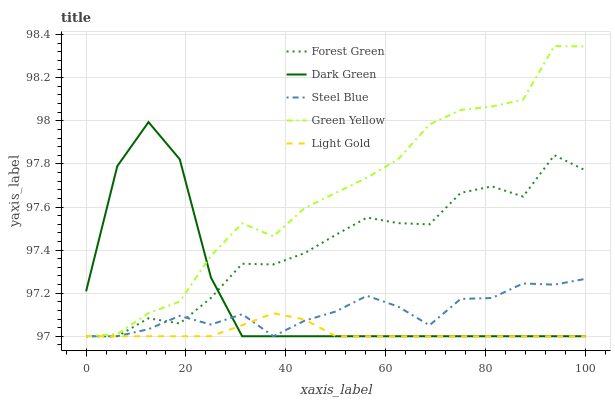Does Light Gold have the minimum area under the curve?
Answer yes or no. Yes. Does Green Yellow have the maximum area under the curve?
Answer yes or no. Yes. Does Green Yellow have the minimum area under the curve?
Answer yes or no. No. Does Light Gold have the maximum area under the curve?
Answer yes or no. No. Is Light Gold the smoothest?
Answer yes or no. Yes. Is Dark Green the roughest?
Answer yes or no. Yes. Is Green Yellow the smoothest?
Answer yes or no. No. Is Green Yellow the roughest?
Answer yes or no. No. Does Forest Green have the lowest value?
Answer yes or no. Yes. Does Green Yellow have the highest value?
Answer yes or no. Yes. Does Light Gold have the highest value?
Answer yes or no. No. Does Green Yellow intersect Dark Green?
Answer yes or no. Yes. Is Green Yellow less than Dark Green?
Answer yes or no. No. Is Green Yellow greater than Dark Green?
Answer yes or no. No. 